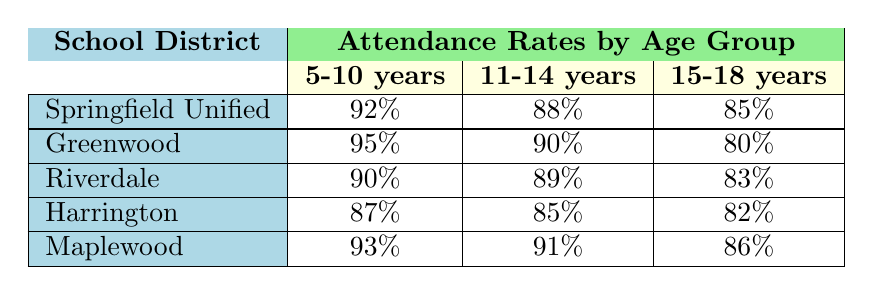What is the attendance rate for 11-14 years in Springfield Unified School District? The table shows that the attendance rate for the age group 11-14 years in Springfield Unified School District is directly listed as 88%.
Answer: 88% Which school district has the highest attendance rate for 5-10 years? By comparing the attendance rates for 5-10 years across all school districts, Greenwood has the highest rate at 95%.
Answer: 95% What is the average attendance rate for 15-18 years across all districts? The attendance rates for 15-18 years are 85%, 80%, 83%, 82%, and 86%. To find the average, sum these rates (85 + 80 + 83 + 82 + 86 = 416), and then divide by the number of districts (416 / 5 = 83.2).
Answer: 83.2% Is the attendance rate for 11-14 years in Maplewood higher than that in Harrington? The attendance rate for 11-14 years in Maplewood is 91%, while in Harrington, it is 85%. Since 91% is greater than 85%, the statement is true.
Answer: Yes What is the difference in attendance rates between 5-10 years and 15-18 years for Greenwood School District? The attendance rate for 5-10 years in Greenwood is 95%, and for 15-18 years, it is 80%. The difference is calculated by subtracting the latter from the former (95 - 80 = 15).
Answer: 15 Which age group has the lowest attendance rate in Riverdale School District? By looking at the attendance rates for Riverdale, we see they are 90% for 5-10 years, 89% for 11-14 years, and 83% for 15-18 years. The lowest rate is 83% for 15-18 years.
Answer: 15-18 years What is the attendance rate for 5-10 years in Harrington, and how does it compare to Maplewood? The attendance rate for 5-10 years in Harrington is 87%, while for Maplewood, it is 93%. Since 93% is greater than 87%, Maplewood has a higher rate.
Answer: 87% (Harrington), 93% (Maplewood) Which school district has the lowest overall attendance rates across all age groups? By calculating the overall attendance rates for each district (Springfield: 88.33%, Greenwood: 88.33%, Riverdale: 87.33%, Harrington: 84.67%, Maplewood: 90%), we find that Harrington has the lowest overall attendance rate at 84.67%.
Answer: Harrington Is it true that all school districts have an attendance rate above 80% for 15-18 years? The attendance rates for 15-18 years are Springfield: 85%, Greenwood: 80%, Riverdale: 83%, Harrington: 82%, and Maplewood: 86%. Since Greenwood is exactly at 80% and not above, the statement is false.
Answer: No 